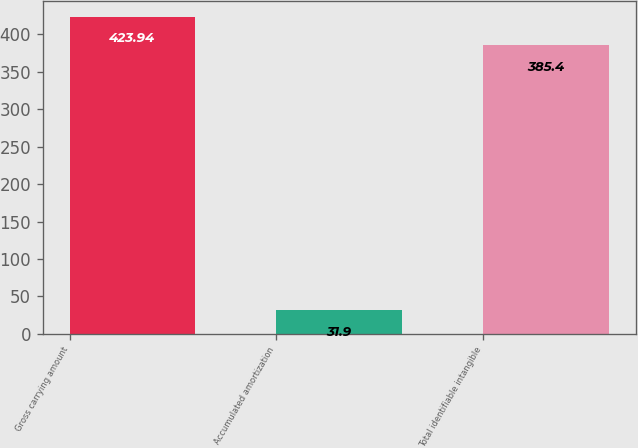Convert chart. <chart><loc_0><loc_0><loc_500><loc_500><bar_chart><fcel>Gross carrying amount<fcel>Accumulated amortization<fcel>Total identifiable intangible<nl><fcel>423.94<fcel>31.9<fcel>385.4<nl></chart> 